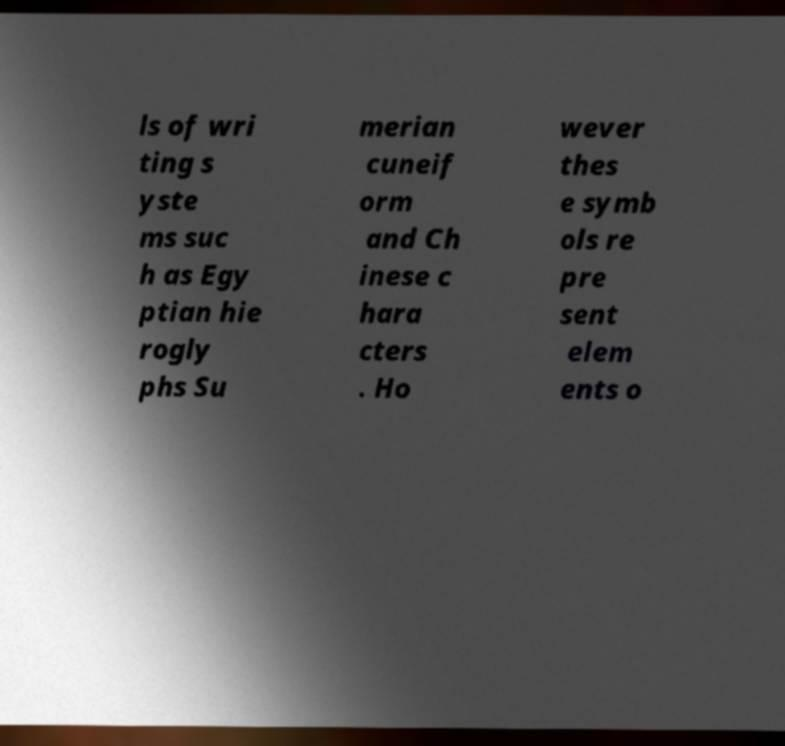Can you read and provide the text displayed in the image?This photo seems to have some interesting text. Can you extract and type it out for me? ls of wri ting s yste ms suc h as Egy ptian hie rogly phs Su merian cuneif orm and Ch inese c hara cters . Ho wever thes e symb ols re pre sent elem ents o 